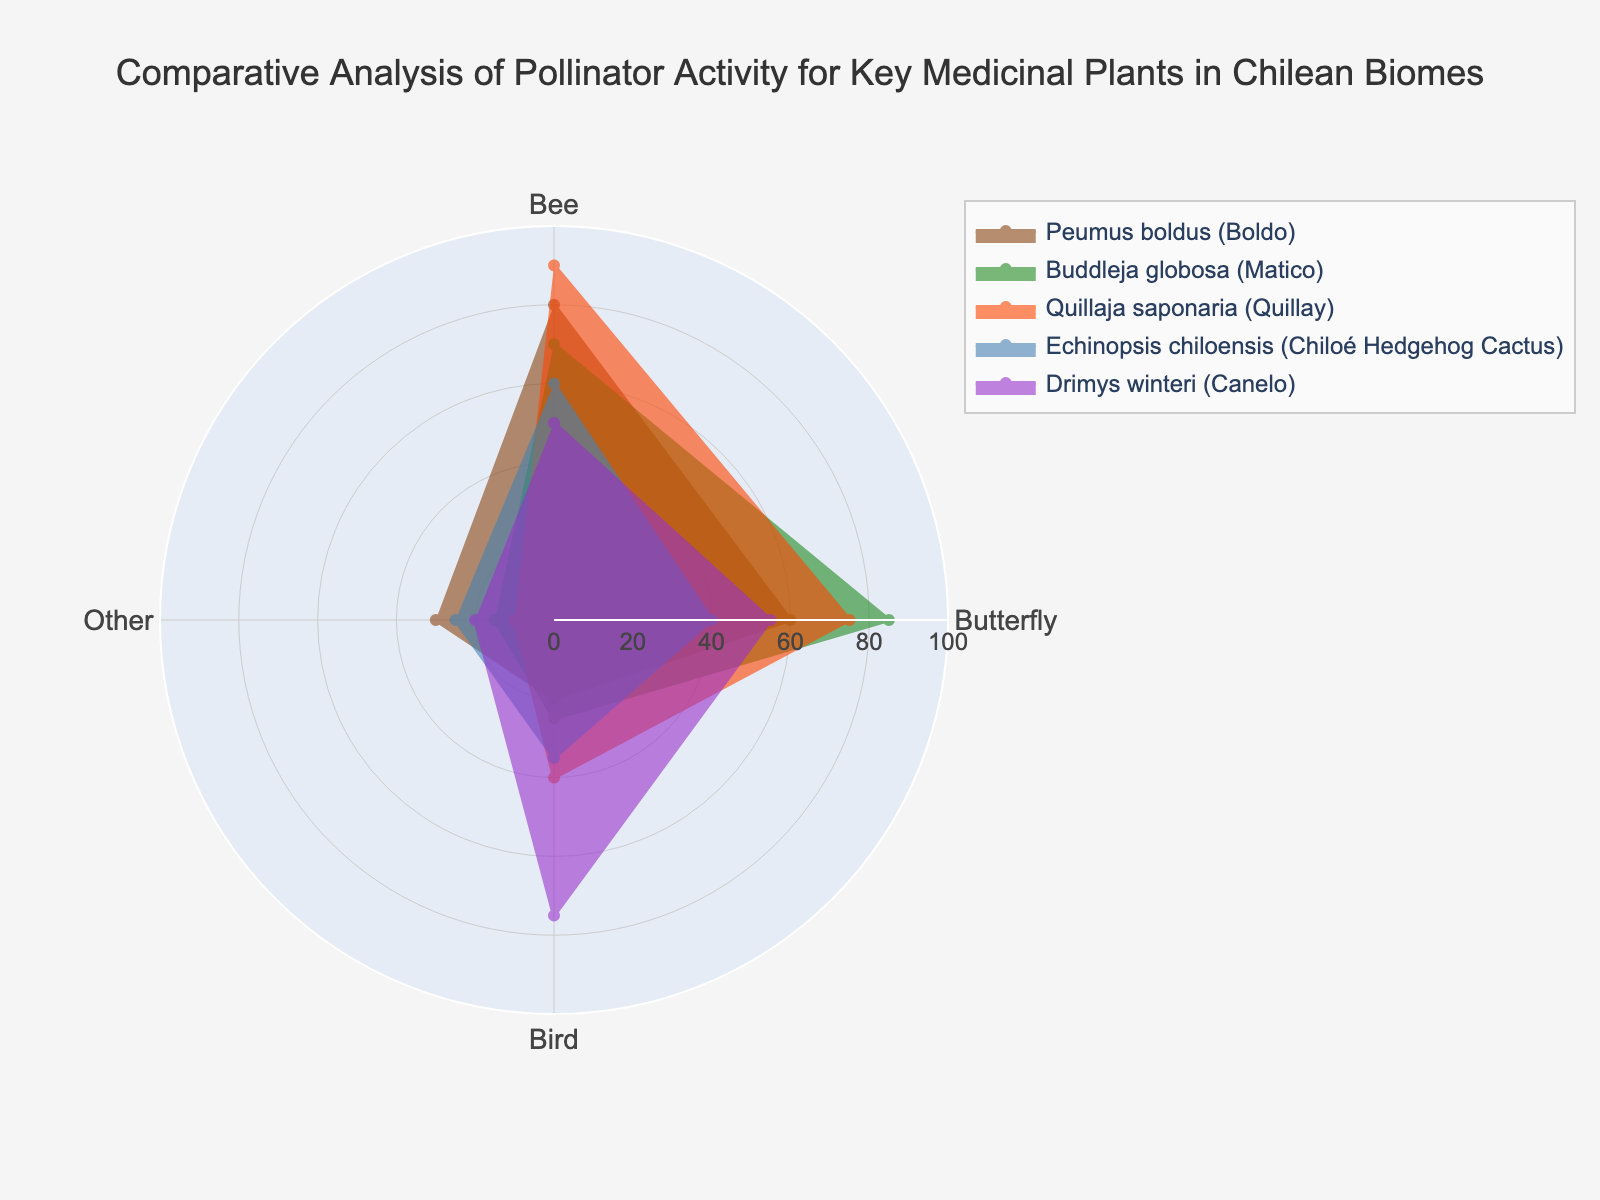What is the title of the radar chart? The title is prominently displayed at the top center of the chart. It provides a summary of what the chart is about, often helping viewers understand the context.
Answer: Comparative Analysis of Pollinator Activity for Key Medicinal Plants in Chilean Biomes Which plant has the highest activity level for bees? By examining the radar chart, we look for the plant that has the most extended segment towards the "Bee" category, which represents the highest value.
Answer: Quillaja saponaria Which pollinator is most attracted to Drimys winteri? We need to look at the segment of Drimys winteri that extends the furthest from the center. The longest segment represents the pollinator with the highest activity level.
Answer: Bird Which plant has the least activity from other pollinators? Look for the shortest segment in the "Other" category across all plants. The plant associated with this segment has the least activity from other pollinators.
Answer: Quillaja saponaria Compare the pollinator activity for butterflies between Peumus boldus and Buddleja globosa. Which plant has higher activity? Check the lengths of the segments for butterflies for these two plants. The plant with the longer segment has higher butterfly activity.
Answer: Buddleja globosa What is the total pollinator activity (sum of all pollinators) for Echinopsis chiloensis? Add the values of all pollinators for Echinopsis chiloensis: 60 (Bee) + 40 (Butterfly) + 35 (Bird) + 25 (Other).
Answer: 160 Which plant shows the most balanced pollinator activity (least variation among the categories)? Look at all segments for each category and determine which plant has the closest-sized segments for its categories, indicating less variation.
Answer: Buddleja globosa What is the difference between the highest and lowest pollinator activities for Quillaja saponaria? Identify the maximum and minimum pollinator values for Quillaja saponaria: 90 (Bee) and 10 (Other). Subtract the lowest from the highest.
Answer: 80 Which pollinator is least attracted to Echinopsis chiloensis? Look for the shortest segment in the radar chart for Echinopsis chiloensis. The category this segment represents is the least attracted pollinator.
Answer: Butterfly How does bird activity for Drimys winteri compare to bee activity for Buddleja globosa? Compare the lengths of the segments for bird activity in Drimys winteri and bee activity in Buddleja globosa. Determine if one is longer, indicating higher activity.
Answer: Bird activity for Drimys winteri is higher 